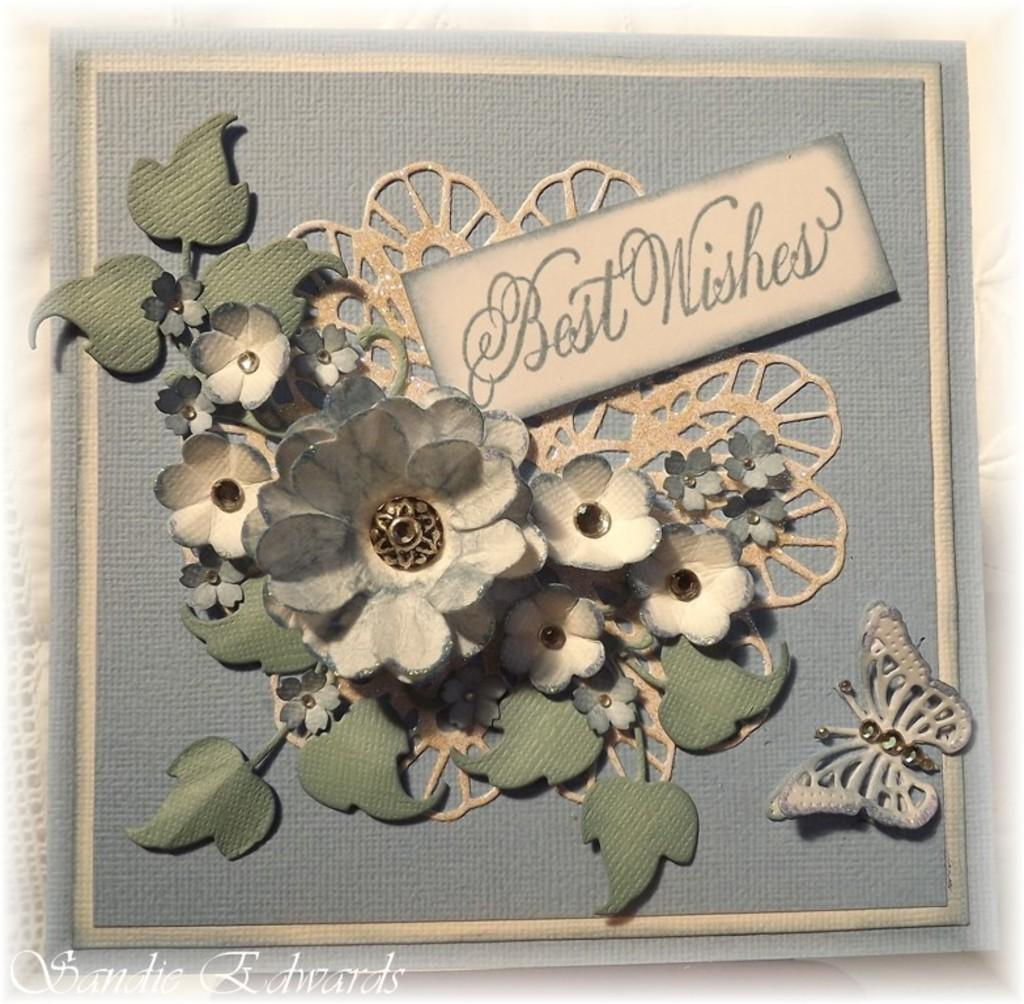What type of flowers are present in the image? There are artificial flowers in the image. What else is present in the image besides the flowers? There are leaves and a butterfly in the image. Where are the flowers, leaves, and butterfly located? They are placed on a surface in the image. What is the purpose of the card in the image? The card with text in the image is likely used for communication or decoration. What type of beam is holding up the roof in the image? There is no roof or beam present in the image; it features artificial flowers, leaves, and a butterfly on a surface. What type of protest is being held in the image? There is no protest or any indication of a protest in the image; it features artificial flowers, leaves, and a butterfly on a surface. 